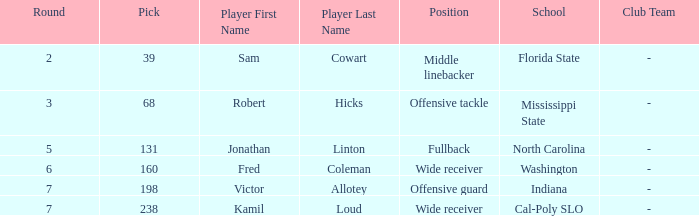Which Player has a Round smaller than 5, and a School/Club Team of florida state? Sam Cowart. 